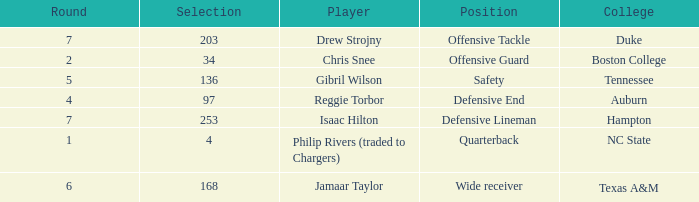Which Selection has a Player of jamaar taylor, and a Round larger than 6? None. 